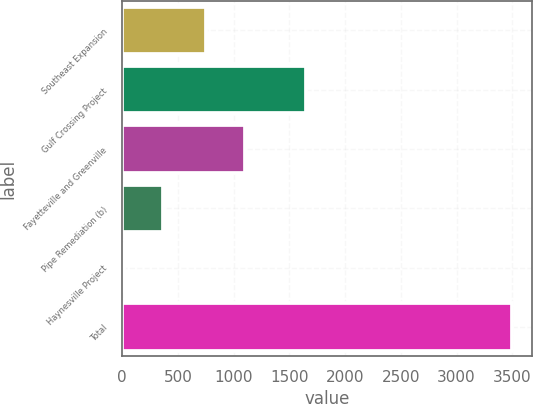Convert chart. <chart><loc_0><loc_0><loc_500><loc_500><bar_chart><fcel>Southeast Expansion<fcel>Gulf Crossing Project<fcel>Fayetteville and Greenville<fcel>Pipe Remediation (b)<fcel>Haynesville Project<fcel>Total<nl><fcel>754<fcel>1649<fcel>1102.5<fcel>364.5<fcel>16<fcel>3501<nl></chart> 